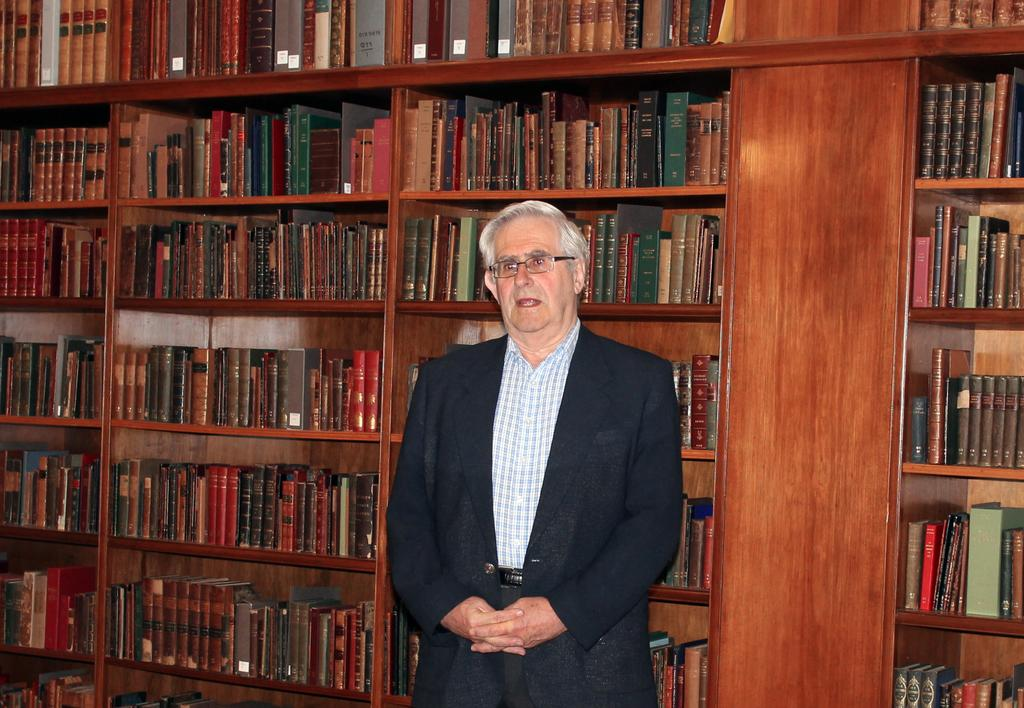Who is the main subject in the image? There is a man standing in the center of the image. What else can be seen in the image besides the man? There is a group of books in the image. How are the books arranged in the image? The books are placed in an order on shelves. How many rabbits are hopping on the road in the image? There are no rabbits or roads present in the image. 